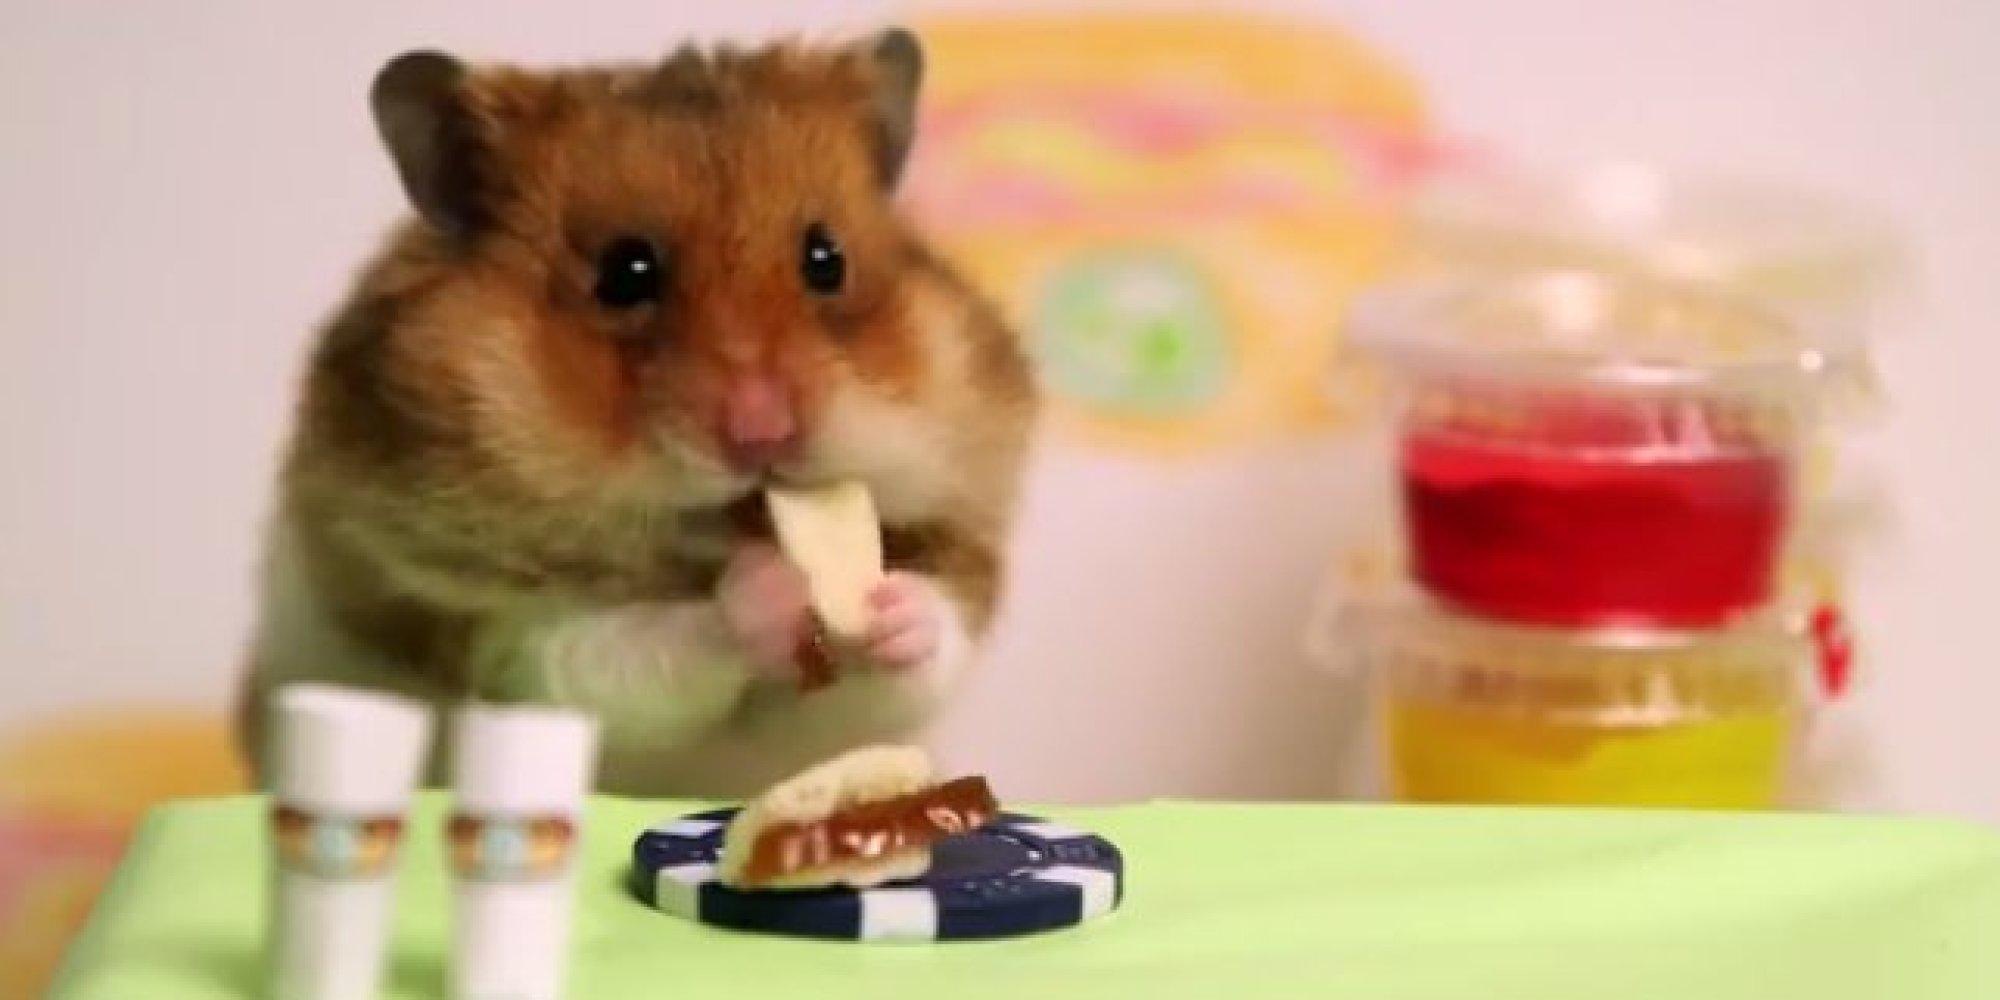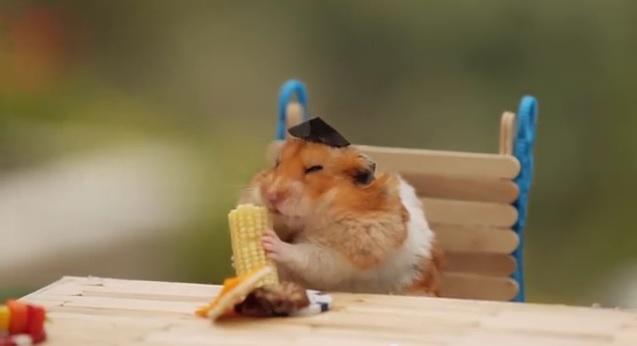The first image is the image on the left, the second image is the image on the right. For the images shown, is this caption "An image contains a rodent wearing a small hat." true? Answer yes or no. Yes. The first image is the image on the left, the second image is the image on the right. Examine the images to the left and right. Is the description "One image shows a hamster in a chair dining at a kind of table and wearing a costume hat." accurate? Answer yes or no. Yes. 